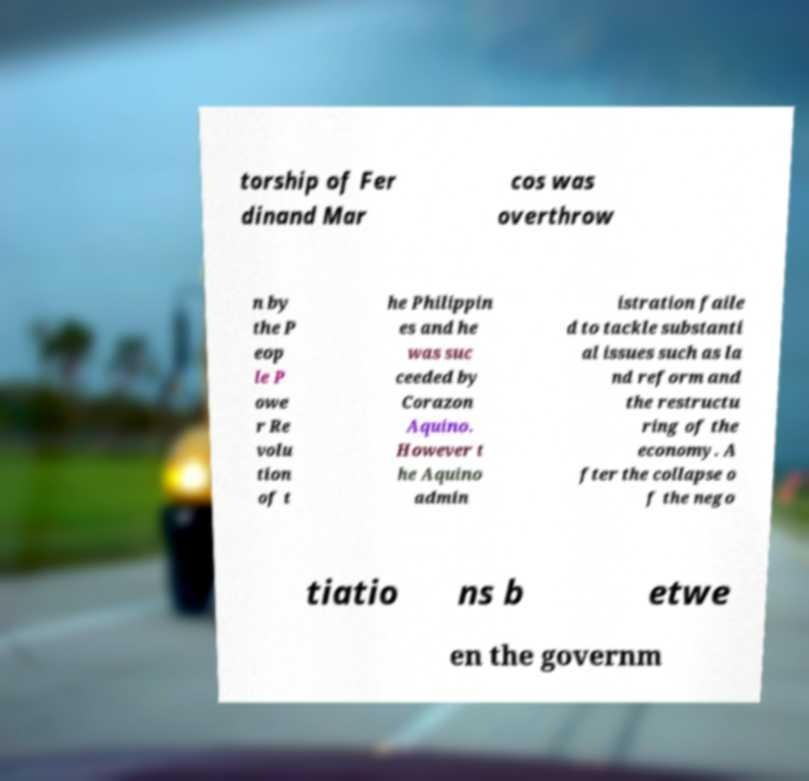I need the written content from this picture converted into text. Can you do that? torship of Fer dinand Mar cos was overthrow n by the P eop le P owe r Re volu tion of t he Philippin es and he was suc ceeded by Corazon Aquino. However t he Aquino admin istration faile d to tackle substanti al issues such as la nd reform and the restructu ring of the economy. A fter the collapse o f the nego tiatio ns b etwe en the governm 